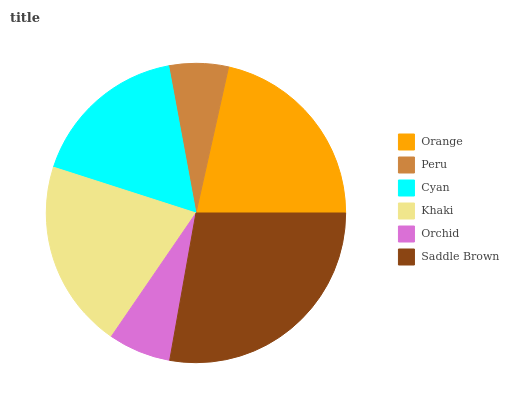Is Peru the minimum?
Answer yes or no. Yes. Is Saddle Brown the maximum?
Answer yes or no. Yes. Is Cyan the minimum?
Answer yes or no. No. Is Cyan the maximum?
Answer yes or no. No. Is Cyan greater than Peru?
Answer yes or no. Yes. Is Peru less than Cyan?
Answer yes or no. Yes. Is Peru greater than Cyan?
Answer yes or no. No. Is Cyan less than Peru?
Answer yes or no. No. Is Khaki the high median?
Answer yes or no. Yes. Is Cyan the low median?
Answer yes or no. Yes. Is Orange the high median?
Answer yes or no. No. Is Peru the low median?
Answer yes or no. No. 